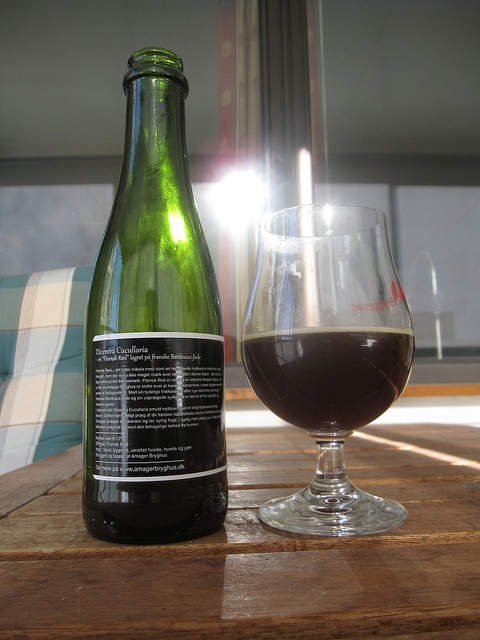Describe the objects in this image and their specific colors. I can see dining table in black, gray, and maroon tones, bottle in black, gray, and darkgreen tones, wine glass in black, darkgray, lightgray, and gray tones, and chair in black, lightgray, teal, darkgray, and gray tones in this image. 